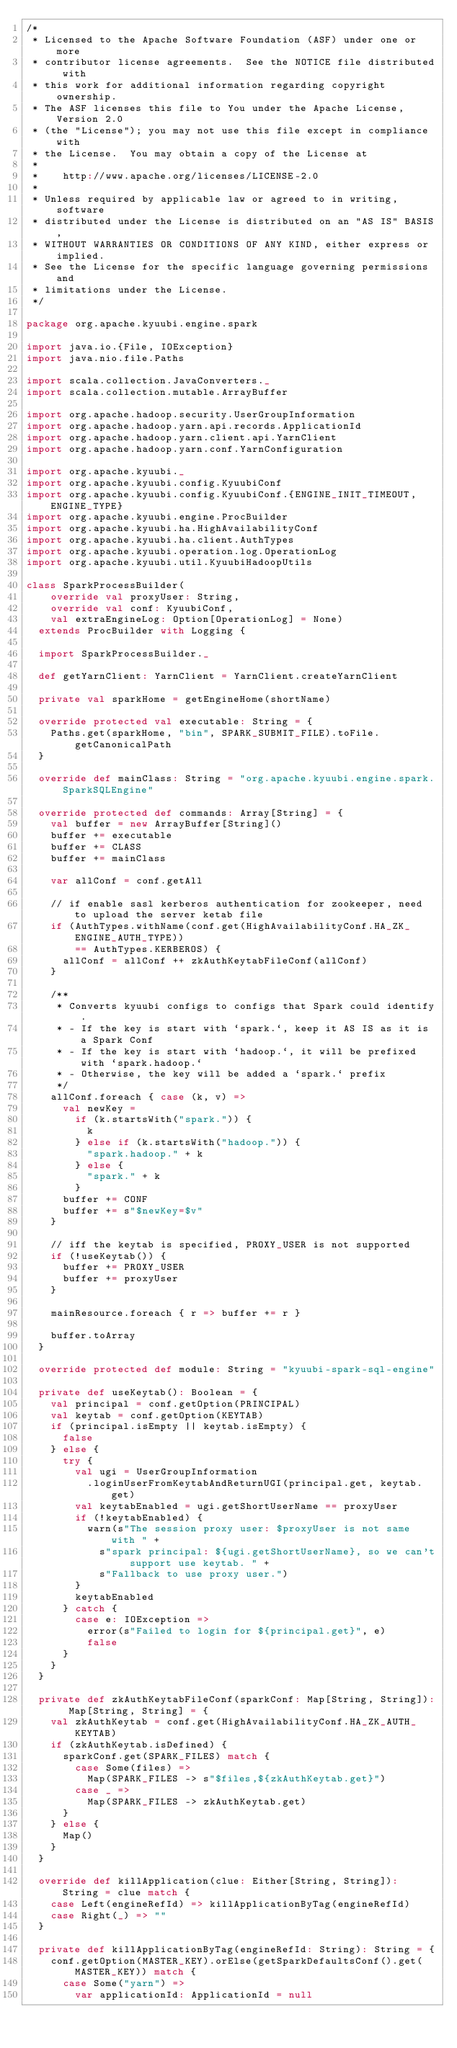Convert code to text. <code><loc_0><loc_0><loc_500><loc_500><_Scala_>/*
 * Licensed to the Apache Software Foundation (ASF) under one or more
 * contributor license agreements.  See the NOTICE file distributed with
 * this work for additional information regarding copyright ownership.
 * The ASF licenses this file to You under the Apache License, Version 2.0
 * (the "License"); you may not use this file except in compliance with
 * the License.  You may obtain a copy of the License at
 *
 *    http://www.apache.org/licenses/LICENSE-2.0
 *
 * Unless required by applicable law or agreed to in writing, software
 * distributed under the License is distributed on an "AS IS" BASIS,
 * WITHOUT WARRANTIES OR CONDITIONS OF ANY KIND, either express or implied.
 * See the License for the specific language governing permissions and
 * limitations under the License.
 */

package org.apache.kyuubi.engine.spark

import java.io.{File, IOException}
import java.nio.file.Paths

import scala.collection.JavaConverters._
import scala.collection.mutable.ArrayBuffer

import org.apache.hadoop.security.UserGroupInformation
import org.apache.hadoop.yarn.api.records.ApplicationId
import org.apache.hadoop.yarn.client.api.YarnClient
import org.apache.hadoop.yarn.conf.YarnConfiguration

import org.apache.kyuubi._
import org.apache.kyuubi.config.KyuubiConf
import org.apache.kyuubi.config.KyuubiConf.{ENGINE_INIT_TIMEOUT, ENGINE_TYPE}
import org.apache.kyuubi.engine.ProcBuilder
import org.apache.kyuubi.ha.HighAvailabilityConf
import org.apache.kyuubi.ha.client.AuthTypes
import org.apache.kyuubi.operation.log.OperationLog
import org.apache.kyuubi.util.KyuubiHadoopUtils

class SparkProcessBuilder(
    override val proxyUser: String,
    override val conf: KyuubiConf,
    val extraEngineLog: Option[OperationLog] = None)
  extends ProcBuilder with Logging {

  import SparkProcessBuilder._

  def getYarnClient: YarnClient = YarnClient.createYarnClient

  private val sparkHome = getEngineHome(shortName)

  override protected val executable: String = {
    Paths.get(sparkHome, "bin", SPARK_SUBMIT_FILE).toFile.getCanonicalPath
  }

  override def mainClass: String = "org.apache.kyuubi.engine.spark.SparkSQLEngine"

  override protected def commands: Array[String] = {
    val buffer = new ArrayBuffer[String]()
    buffer += executable
    buffer += CLASS
    buffer += mainClass

    var allConf = conf.getAll

    // if enable sasl kerberos authentication for zookeeper, need to upload the server ketab file
    if (AuthTypes.withName(conf.get(HighAvailabilityConf.HA_ZK_ENGINE_AUTH_TYPE))
        == AuthTypes.KERBEROS) {
      allConf = allConf ++ zkAuthKeytabFileConf(allConf)
    }

    /**
     * Converts kyuubi configs to configs that Spark could identify.
     * - If the key is start with `spark.`, keep it AS IS as it is a Spark Conf
     * - If the key is start with `hadoop.`, it will be prefixed with `spark.hadoop.`
     * - Otherwise, the key will be added a `spark.` prefix
     */
    allConf.foreach { case (k, v) =>
      val newKey =
        if (k.startsWith("spark.")) {
          k
        } else if (k.startsWith("hadoop.")) {
          "spark.hadoop." + k
        } else {
          "spark." + k
        }
      buffer += CONF
      buffer += s"$newKey=$v"
    }

    // iff the keytab is specified, PROXY_USER is not supported
    if (!useKeytab()) {
      buffer += PROXY_USER
      buffer += proxyUser
    }

    mainResource.foreach { r => buffer += r }

    buffer.toArray
  }

  override protected def module: String = "kyuubi-spark-sql-engine"

  private def useKeytab(): Boolean = {
    val principal = conf.getOption(PRINCIPAL)
    val keytab = conf.getOption(KEYTAB)
    if (principal.isEmpty || keytab.isEmpty) {
      false
    } else {
      try {
        val ugi = UserGroupInformation
          .loginUserFromKeytabAndReturnUGI(principal.get, keytab.get)
        val keytabEnabled = ugi.getShortUserName == proxyUser
        if (!keytabEnabled) {
          warn(s"The session proxy user: $proxyUser is not same with " +
            s"spark principal: ${ugi.getShortUserName}, so we can't support use keytab. " +
            s"Fallback to use proxy user.")
        }
        keytabEnabled
      } catch {
        case e: IOException =>
          error(s"Failed to login for ${principal.get}", e)
          false
      }
    }
  }

  private def zkAuthKeytabFileConf(sparkConf: Map[String, String]): Map[String, String] = {
    val zkAuthKeytab = conf.get(HighAvailabilityConf.HA_ZK_AUTH_KEYTAB)
    if (zkAuthKeytab.isDefined) {
      sparkConf.get(SPARK_FILES) match {
        case Some(files) =>
          Map(SPARK_FILES -> s"$files,${zkAuthKeytab.get}")
        case _ =>
          Map(SPARK_FILES -> zkAuthKeytab.get)
      }
    } else {
      Map()
    }
  }

  override def killApplication(clue: Either[String, String]): String = clue match {
    case Left(engineRefId) => killApplicationByTag(engineRefId)
    case Right(_) => ""
  }

  private def killApplicationByTag(engineRefId: String): String = {
    conf.getOption(MASTER_KEY).orElse(getSparkDefaultsConf().get(MASTER_KEY)) match {
      case Some("yarn") =>
        var applicationId: ApplicationId = null</code> 